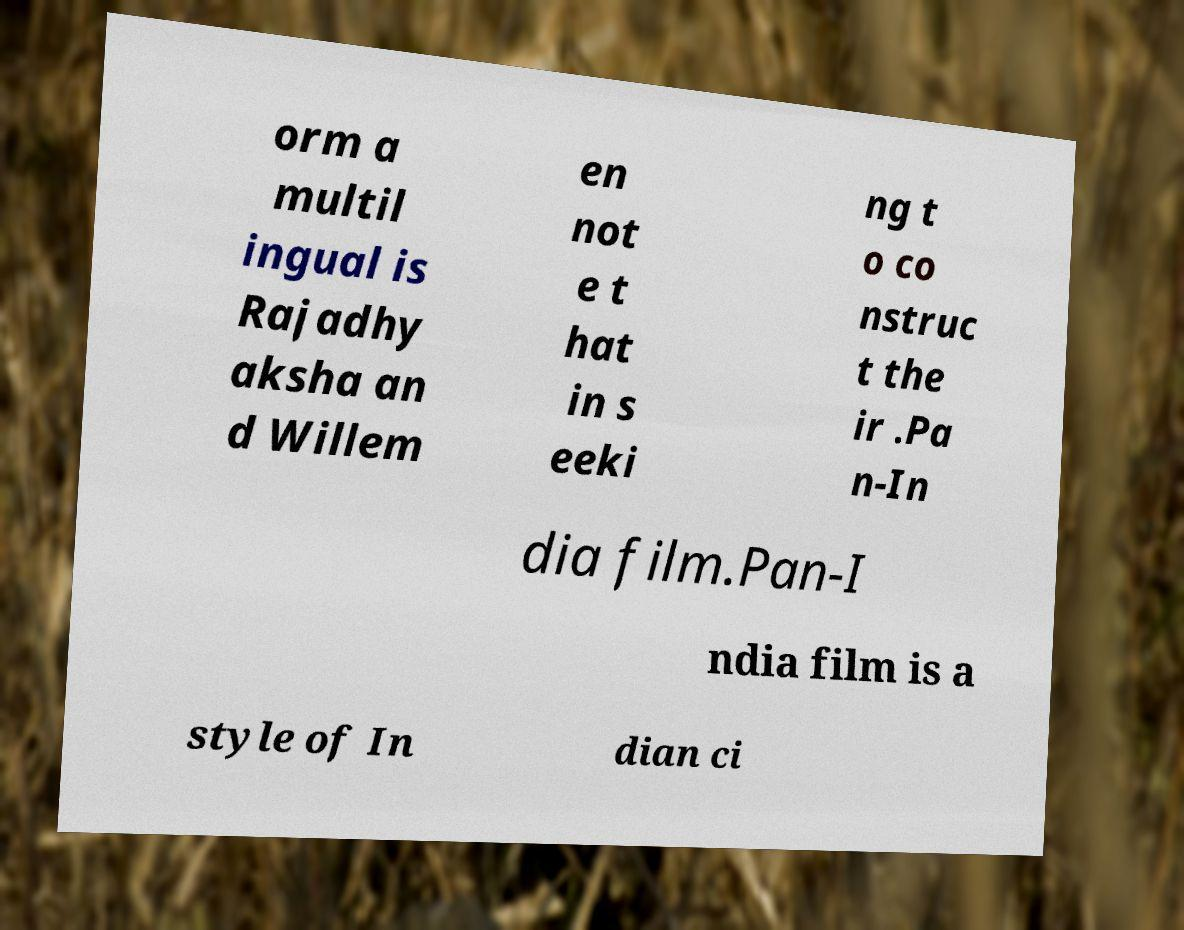For documentation purposes, I need the text within this image transcribed. Could you provide that? orm a multil ingual is Rajadhy aksha an d Willem en not e t hat in s eeki ng t o co nstruc t the ir .Pa n-In dia film.Pan-I ndia film is a style of In dian ci 